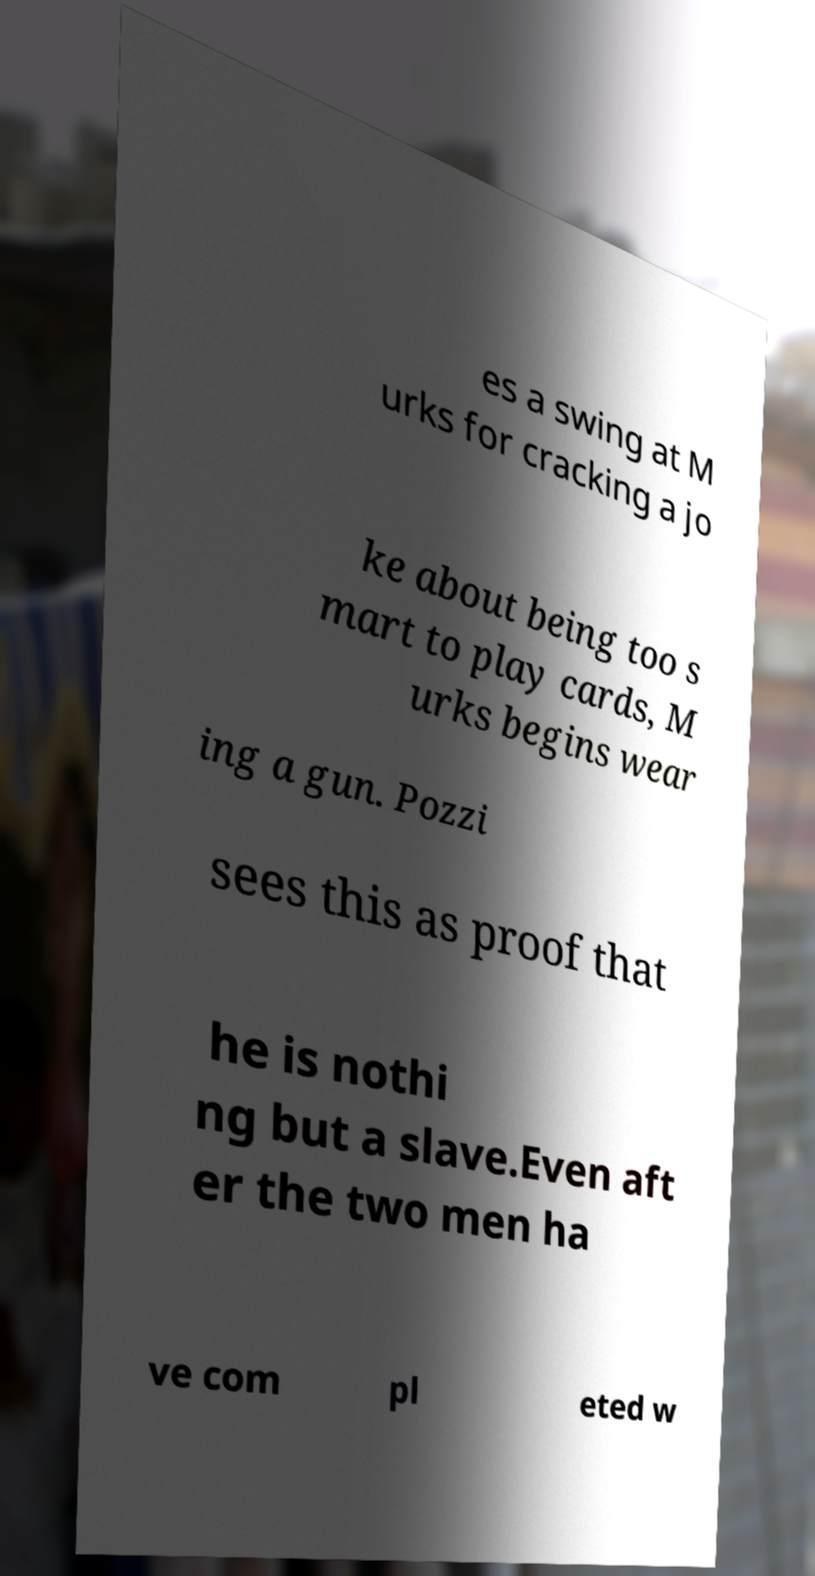Can you accurately transcribe the text from the provided image for me? es a swing at M urks for cracking a jo ke about being too s mart to play cards, M urks begins wear ing a gun. Pozzi sees this as proof that he is nothi ng but a slave.Even aft er the two men ha ve com pl eted w 